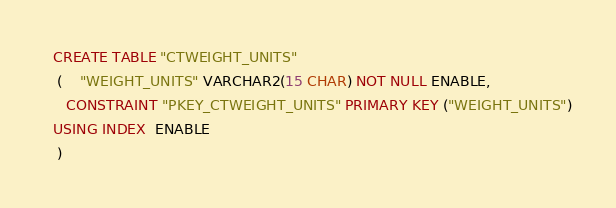<code> <loc_0><loc_0><loc_500><loc_500><_SQL_>
  CREATE TABLE "CTWEIGHT_UNITS" 
   (	"WEIGHT_UNITS" VARCHAR2(15 CHAR) NOT NULL ENABLE, 
	 CONSTRAINT "PKEY_CTWEIGHT_UNITS" PRIMARY KEY ("WEIGHT_UNITS")
  USING INDEX  ENABLE
   ) </code> 